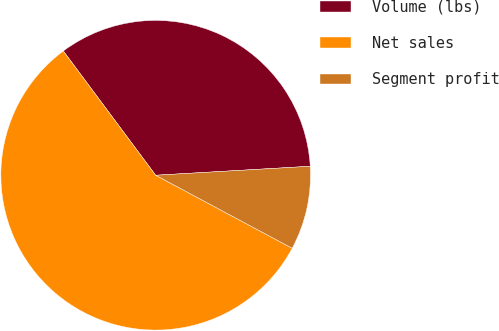Convert chart to OTSL. <chart><loc_0><loc_0><loc_500><loc_500><pie_chart><fcel>Volume (lbs)<fcel>Net sales<fcel>Segment profit<nl><fcel>34.25%<fcel>57.01%<fcel>8.74%<nl></chart> 